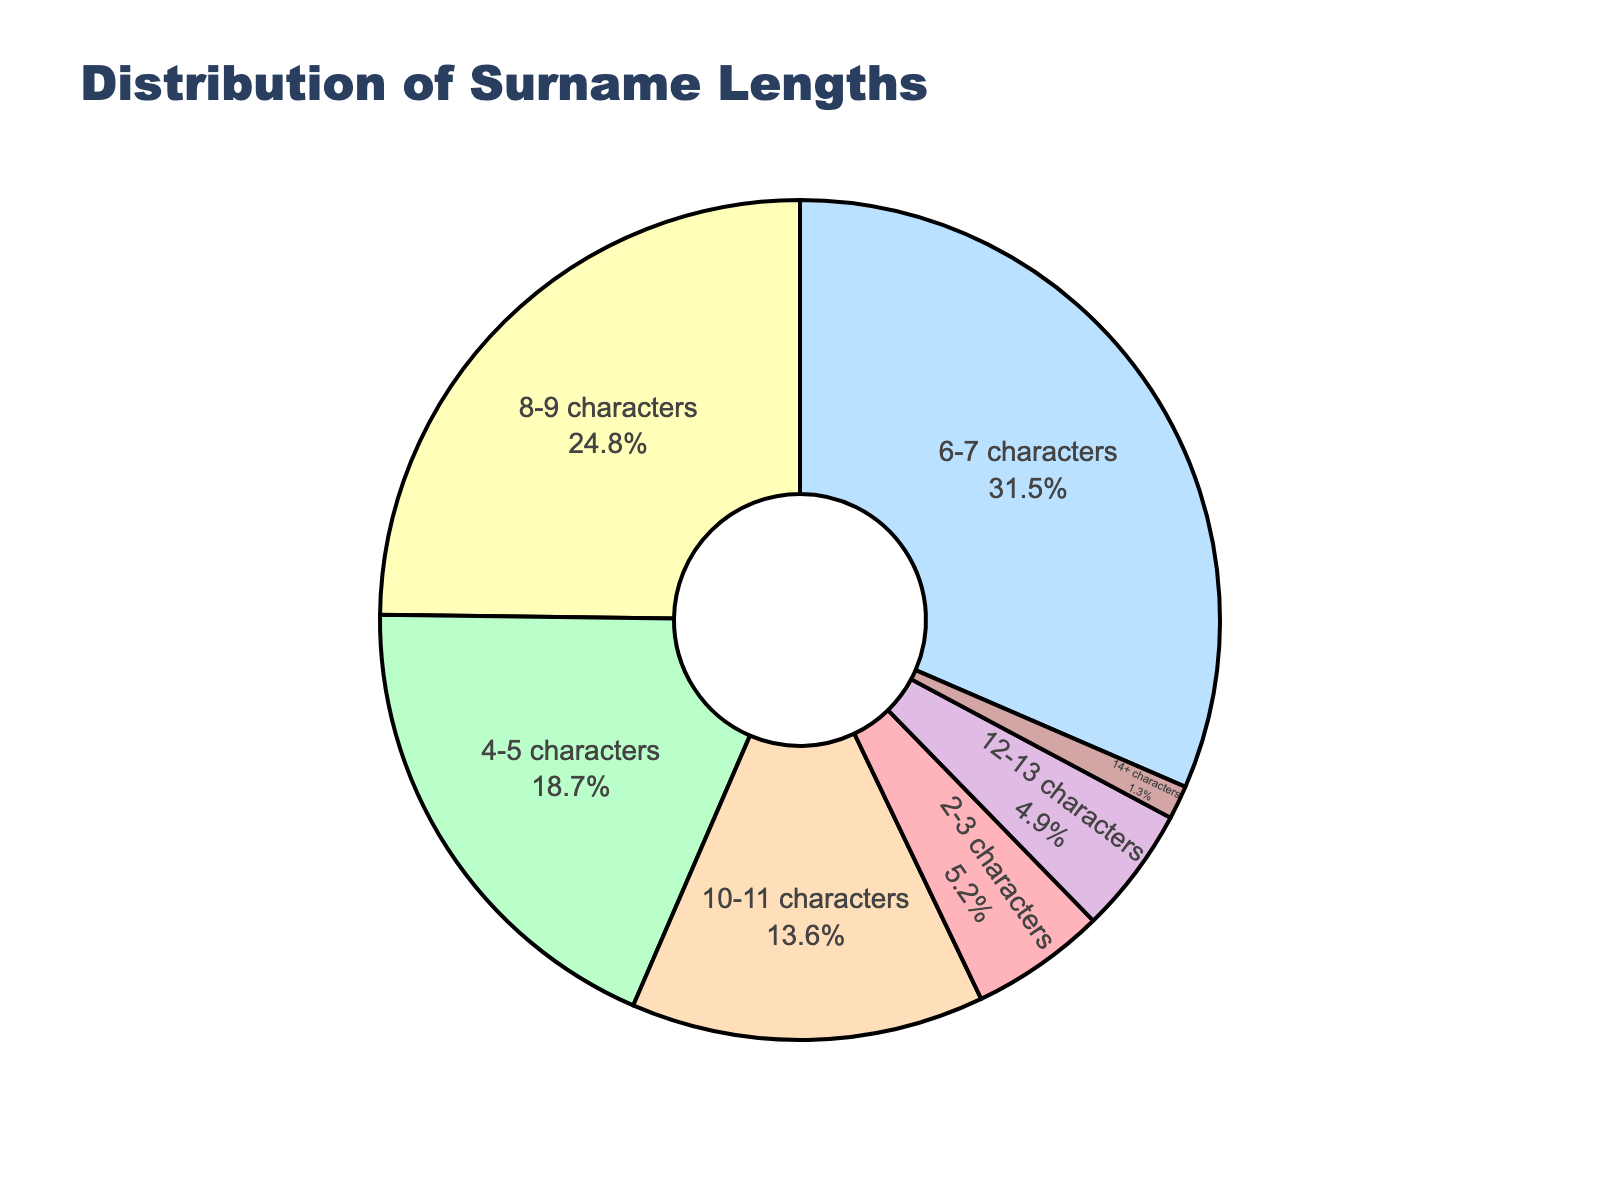What's the percentage of surnames with 4-5 characters? The figure shows percentages of different surname length categories. We need to locate the section labeled "4-5 characters" and read the percentage value.
Answer: 18.7% What is the combined percentage of surnames with 8-9 characters and 10-11 characters? Locate the segments labeled "8-9 characters" and "10-11 characters". Their percentages are 24.8% and 13.6%, respectively. Add these values together: 24.8% + 13.6% = 38.4%
Answer: 38.4% Which surname length category has the smallest percentage? Look for the smallest value in the pie chart's segments. The section labeled "14+ characters" shows 1.3%, which is the smallest.
Answer: 14+ characters Are there more surnames with 6-7 characters than 12-13 characters? Find the percentages for both categories: "6-7 characters" is 31.5% and "12-13 characters" is 4.9%. Since 31.5% is greater than 4.9%, there are more surnames with 6-7 characters.
Answer: Yes What is the difference in percentage between the shortest (2-3 characters) and the longest (14+ characters) surname lengths? Find the percentages for "2-3 characters" and "14+ characters". They are 5.2% and 1.3% respectively. Subtract the smaller percentage from the larger one: 5.2% - 1.3% = 3.9%
Answer: 3.9% Which color represents the 6-7 characters category, and is it the largest segment in the pie chart? In the chart, the 6-7 characters category is represented by the largest segment. Its color appears next to its label. After confirming the percentages, it is indeed the largest with 31.5%. The color representing it will be visible in the chart's legend or segment.
Answer: Yes, (Color based on figure) What is the average percentage of the 6-7 characters and 4-5 characters categories? Locate the percentages: "6-7 characters" is 31.5% and "4-5 characters" is 18.7%. Calculate the average: (31.5% + 18.7%) / 2 = 25.1%
Answer: 25.1% Compare the percentages of surnames with 2-3 characters and 12-13 characters. Which has a higher percentage? Check the segments labeled "2-3 characters" and "12-13 characters". Their percentages are 5.2% and 4.9%, respectively. Since 5.2% is greater than 4.9%, the "2-3 characters" category has a higher percentage.
Answer: 2-3 characters How much more prevalent are 8-9 character surnames compared to 2-3 character surnames? Identify the percentages of "8-9 characters" and "2-3 characters". They are 24.8% and 5.2%, respectively. Subtract the smaller percentage from the larger one: 24.8% - 5.2% = 19.6%
Answer: 19.6% Which category makes up nearly a quarter of the surnames? Look for a percentage close to 25% in the chart. The segment "8-9 characters" is 24.8%, which is nearly a quarter.
Answer: 8-9 characters 